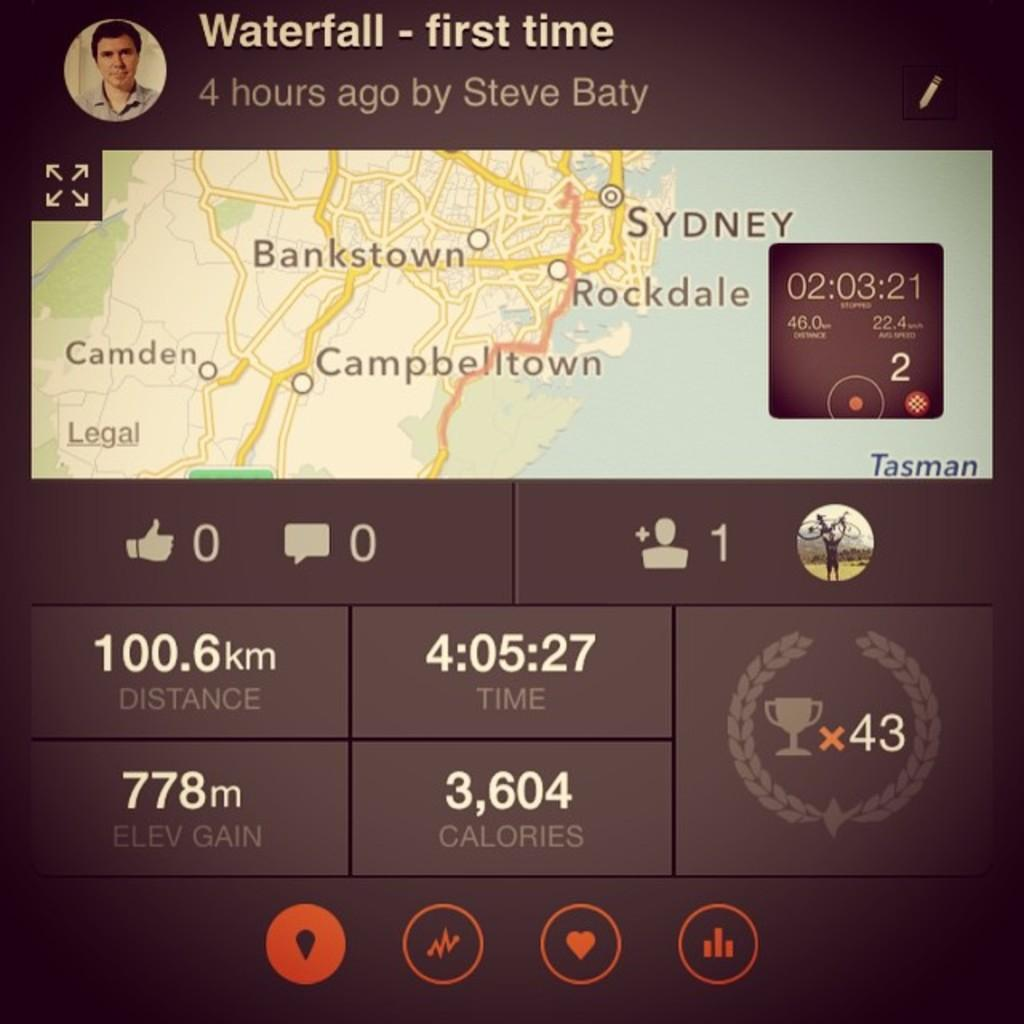What type of document or diagram is shown in the image? There is a route map in the image. What device or tool might be used to track time in the image? There is a timer in the image. What type of symbols or images can be seen in the image? There are icons in the image. Can you describe the person visible in the image? There is a person visible in the image, but no specific details about their appearance or actions are provided. What type of information is conveyed through text in the image? There is text in the image, but the specific content or message is not mentioned. How might the image have been captured or created? The image appears to be taken from a screen. What type of education can be seen in the image? There is no reference to education in the image; it features a route map, timer, icons, a person, text, and appears to be taken from a screen. What type of knife is being used by the person in the image? There is no knife present in the image; it features a route map, timer, icons, a person, text, and appears to be taken from a screen. 